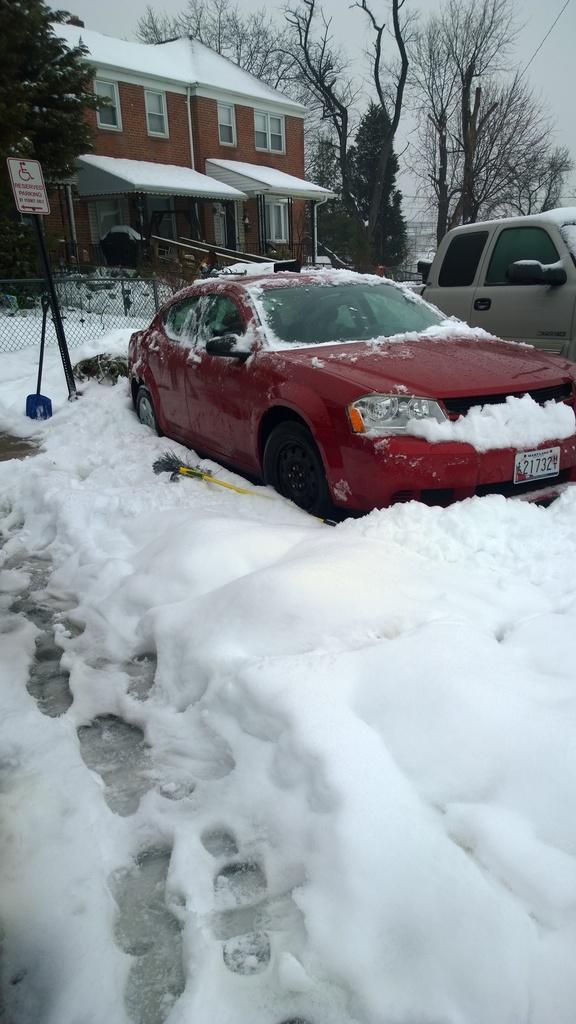How would you summarize this image in a sentence or two? This is the picture of a place where we have a building, cars on the snow floor and around there are some trees and cars. 